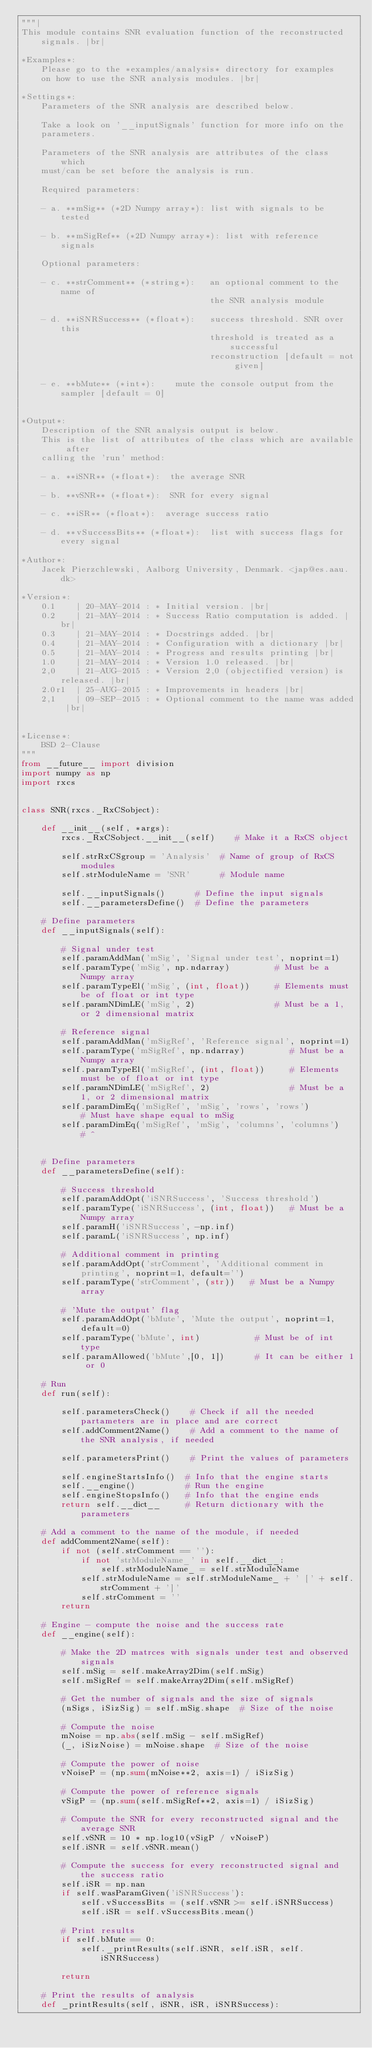Convert code to text. <code><loc_0><loc_0><loc_500><loc_500><_Python_>"""|
This module contains SNR evaluation function of the reconstructed signals. |br|

*Examples*:
    Please go to the *examples/analysis* directory for examples 
    on how to use the SNR analysis modules. |br|

*Settings*:
    Parameters of the SNR analysis are described below.

    Take a look on '__inputSignals' function for more info on the 
    parameters.

    Parameters of the SNR analysis are attributes of the class which 
    must/can be set before the analysis is run.

    Required parameters:

    - a. **mSig** (*2D Numpy array*): list with signals to be tested

    - b. **mSigRef** (*2D Numpy array*): list with reference signals

    Optional parameters:

    - c. **strComment** (*string*):   an optional comment to the name of 
                                      the SNR analysis module

    - d. **iSNRSuccess** (*float*):   success threshold. SNR over this 
                                      threshold is treated as a successful 
                                      reconstruction [default = not given]

    - e. **bMute** (*int*):    mute the console output from the sampler [default = 0]


*Output*:
    Description of the SNR analysis output is below.
    This is the list of attributes of the class which are available after
    calling the 'run' method:

    - a. **iSNR** (*float*):  the average SNR 

    - b. **vSNR** (*float*):  SNR for every signal

    - c. **iSR** (*float*):  average success ratio

    - d. **vSuccessBits** (*float*):  list with success flags for every signal

*Author*:
    Jacek Pierzchlewski, Aalborg University, Denmark. <jap@es.aau.dk>

*Version*:
    0.1    | 20-MAY-2014 : * Initial version. |br|
    0.2    | 21-MAY-2014 : * Success Ratio computation is added. |br|
    0.3    | 21-MAY-2014 : * Docstrings added. |br|
    0.4    | 21-MAY-2014 : * Configuration with a dictionary |br|
    0.5    | 21-MAY-2014 : * Progress and results printing |br|
    1.0    | 21-MAY-2014 : * Version 1.0 released. |br|
    2,0    | 21-AUG-2015 : * Version 2,0 (objectified version) is released. |br|
    2.0r1  | 25-AUG-2015 : * Improvements in headers |br|
    2,1    | 09-SEP-2015 : * Optional comment to the name was added |br|


*License*:
    BSD 2-Clause
"""
from __future__ import division
import numpy as np
import rxcs


class SNR(rxcs._RxCSobject):

    def __init__(self, *args):
        rxcs._RxCSobject.__init__(self)    # Make it a RxCS object 
        
        self.strRxCSgroup = 'Analysis'  # Name of group of RxCS modules
        self.strModuleName = 'SNR'      # Module name

        self.__inputSignals()      # Define the input signals
        self.__parametersDefine()  # Define the parameters

    # Define parameters
    def __inputSignals(self):

        # Signal under test
        self.paramAddMan('mSig', 'Signal under test', noprint=1)
        self.paramType('mSig', np.ndarray)         # Must be a Numpy array
        self.paramTypeEl('mSig', (int, float))     # Elements must be of float or int type
        self.paramNDimLE('mSig', 2)                # Must be a 1, or 2 dimensional matrix

        # Reference signal
        self.paramAddMan('mSigRef', 'Reference signal', noprint=1)
        self.paramType('mSigRef', np.ndarray)         # Must be a Numpy array
        self.paramTypeEl('mSigRef', (int, float))     # Elements must be of float or int type
        self.paramNDimLE('mSigRef', 2)                # Must be a 1, or 2 dimensional matrix
        self.paramDimEq('mSigRef', 'mSig', 'rows', 'rows')         # Must have shape equal to mSig
        self.paramDimEq('mSigRef', 'mSig', 'columns', 'columns')   # ^


    # Define parameters
    def __parametersDefine(self):

        # Success threshold
        self.paramAddOpt('iSNRSuccess', 'Success threshold')
        self.paramType('iSNRSuccess', (int, float))   # Must be a Numpy array
        self.paramH('iSNRSuccess', -np.inf)
        self.paramL('iSNRSuccess', np.inf)

        # Additional comment in printing
        self.paramAddOpt('strComment', 'Additional comment in printing', noprint=1, default='')
        self.paramType('strComment', (str))   # Must be a Numpy array

        # 'Mute the output' flag
        self.paramAddOpt('bMute', 'Mute the output', noprint=1, default=0)
        self.paramType('bMute', int)           # Must be of int type
        self.paramAllowed('bMute',[0, 1])      # It can be either 1 or 0

    # Run
    def run(self):
        
        self.parametersCheck()    # Check if all the needed partameters are in place and are correct
        self.addComment2Name()    # Add a comment to the name of the SNR analysis, if needed

        self.parametersPrint()    # Print the values of parameters

        self.engineStartsInfo()  # Info that the engine starts
        self.__engine()          # Run the engine
        self.engineStopsInfo()   # Info that the engine ends
        return self.__dict__     # Return dictionary with the parameters

    # Add a comment to the name of the module, if needed
    def addComment2Name(self):
        if not (self.strComment == ''):
            if not 'strModuleName_' in self.__dict__:
                self.strModuleName_ = self.strModuleName
            self.strModuleName = self.strModuleName_ + ' [' + self.strComment + ']'       
            self.strComment = ''
        return
        
    # Engine - compute the noise and the success rate
    def __engine(self):

        # Make the 2D matrces with signals under test and observed signals
        self.mSig = self.makeArray2Dim(self.mSig)
        self.mSigRef = self.makeArray2Dim(self.mSigRef)

        # Get the number of signals and the size of signals
        (nSigs, iSizSig) = self.mSig.shape  # Size of the noise

        # Compute the noise
        mNoise = np.abs(self.mSig - self.mSigRef)
        (_, iSizNoise) = mNoise.shape  # Size of the noise

        # Compute the power of noise
        vNoiseP = (np.sum(mNoise**2, axis=1) / iSizSig)

        # Compute the power of reference signals
        vSigP = (np.sum(self.mSigRef**2, axis=1) / iSizSig)

        # Compute the SNR for every reconstructed signal and the average SNR
        self.vSNR = 10 * np.log10(vSigP / vNoiseP)
        self.iSNR = self.vSNR.mean()

        # Compute the success for every reconstructed signal and the success ratio
        self.iSR = np.nan        
        if self.wasParamGiven('iSNRSuccess'):
            self.vSuccessBits = (self.vSNR >= self.iSNRSuccess)
            self.iSR = self.vSuccessBits.mean()

        # Print results
        if self.bMute == 0:
            self._printResults(self.iSNR, self.iSR, self.iSNRSuccess)

        return

    # Print the results of analysis
    def _printResults(self, iSNR, iSR, iSNRSuccess):
</code> 